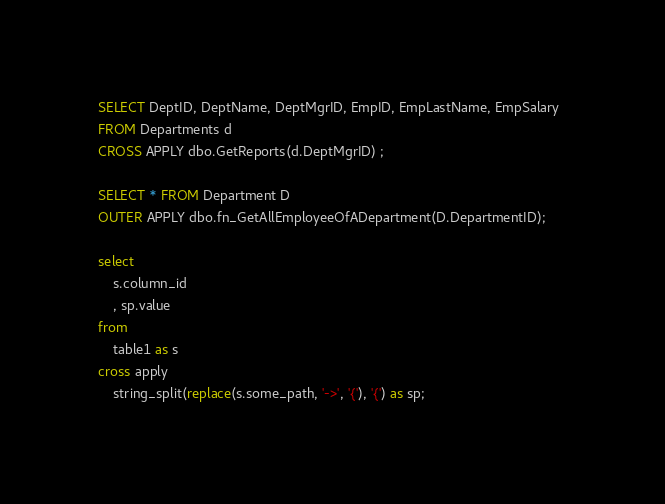Convert code to text. <code><loc_0><loc_0><loc_500><loc_500><_SQL_>SELECT DeptID, DeptName, DeptMgrID, EmpID, EmpLastName, EmpSalary  
FROM Departments d    
CROSS APPLY dbo.GetReports(d.DeptMgrID) ;  

SELECT * FROM Department D 
OUTER APPLY dbo.fn_GetAllEmployeeOfADepartment(D.DepartmentID);

select
	s.column_id
	, sp.value 
from
	table1 as s
cross apply 
	string_split(replace(s.some_path, '->', '{'), '{') as sp;
</code> 